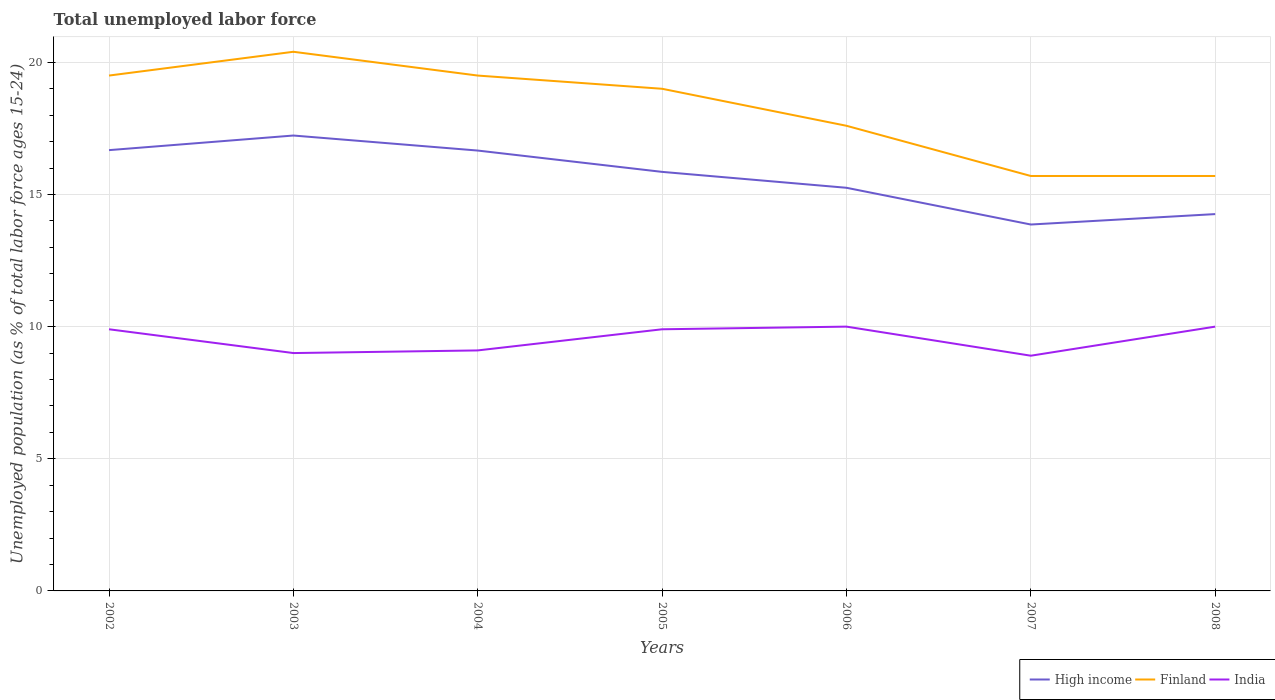Does the line corresponding to Finland intersect with the line corresponding to India?
Your answer should be very brief. No. Across all years, what is the maximum percentage of unemployed population in in High income?
Make the answer very short. 13.86. In which year was the percentage of unemployed population in in Finland maximum?
Your answer should be compact. 2007. What is the total percentage of unemployed population in in High income in the graph?
Make the answer very short. 1.42. What is the difference between the highest and the second highest percentage of unemployed population in in India?
Ensure brevity in your answer.  1.1. What is the difference between the highest and the lowest percentage of unemployed population in in India?
Offer a terse response. 4. How many years are there in the graph?
Give a very brief answer. 7. How many legend labels are there?
Your response must be concise. 3. What is the title of the graph?
Your response must be concise. Total unemployed labor force. Does "Israel" appear as one of the legend labels in the graph?
Your answer should be compact. No. What is the label or title of the Y-axis?
Provide a short and direct response. Unemployed population (as % of total labor force ages 15-24). What is the Unemployed population (as % of total labor force ages 15-24) of High income in 2002?
Your answer should be very brief. 16.68. What is the Unemployed population (as % of total labor force ages 15-24) of Finland in 2002?
Provide a short and direct response. 19.5. What is the Unemployed population (as % of total labor force ages 15-24) in India in 2002?
Your answer should be very brief. 9.9. What is the Unemployed population (as % of total labor force ages 15-24) of High income in 2003?
Your answer should be very brief. 17.23. What is the Unemployed population (as % of total labor force ages 15-24) of Finland in 2003?
Keep it short and to the point. 20.4. What is the Unemployed population (as % of total labor force ages 15-24) of High income in 2004?
Ensure brevity in your answer.  16.66. What is the Unemployed population (as % of total labor force ages 15-24) in Finland in 2004?
Keep it short and to the point. 19.5. What is the Unemployed population (as % of total labor force ages 15-24) in India in 2004?
Provide a succinct answer. 9.1. What is the Unemployed population (as % of total labor force ages 15-24) of High income in 2005?
Your answer should be very brief. 15.86. What is the Unemployed population (as % of total labor force ages 15-24) in Finland in 2005?
Ensure brevity in your answer.  19. What is the Unemployed population (as % of total labor force ages 15-24) in India in 2005?
Offer a terse response. 9.9. What is the Unemployed population (as % of total labor force ages 15-24) of High income in 2006?
Your response must be concise. 15.25. What is the Unemployed population (as % of total labor force ages 15-24) of Finland in 2006?
Your answer should be very brief. 17.6. What is the Unemployed population (as % of total labor force ages 15-24) in India in 2006?
Your answer should be very brief. 10. What is the Unemployed population (as % of total labor force ages 15-24) in High income in 2007?
Provide a succinct answer. 13.86. What is the Unemployed population (as % of total labor force ages 15-24) in Finland in 2007?
Offer a terse response. 15.7. What is the Unemployed population (as % of total labor force ages 15-24) of India in 2007?
Provide a succinct answer. 8.9. What is the Unemployed population (as % of total labor force ages 15-24) in High income in 2008?
Ensure brevity in your answer.  14.26. What is the Unemployed population (as % of total labor force ages 15-24) in Finland in 2008?
Provide a short and direct response. 15.7. Across all years, what is the maximum Unemployed population (as % of total labor force ages 15-24) of High income?
Ensure brevity in your answer.  17.23. Across all years, what is the maximum Unemployed population (as % of total labor force ages 15-24) of Finland?
Make the answer very short. 20.4. Across all years, what is the minimum Unemployed population (as % of total labor force ages 15-24) in High income?
Offer a terse response. 13.86. Across all years, what is the minimum Unemployed population (as % of total labor force ages 15-24) in Finland?
Your answer should be compact. 15.7. Across all years, what is the minimum Unemployed population (as % of total labor force ages 15-24) in India?
Ensure brevity in your answer.  8.9. What is the total Unemployed population (as % of total labor force ages 15-24) of High income in the graph?
Provide a succinct answer. 109.8. What is the total Unemployed population (as % of total labor force ages 15-24) in Finland in the graph?
Ensure brevity in your answer.  127.4. What is the total Unemployed population (as % of total labor force ages 15-24) in India in the graph?
Keep it short and to the point. 66.8. What is the difference between the Unemployed population (as % of total labor force ages 15-24) of High income in 2002 and that in 2003?
Ensure brevity in your answer.  -0.55. What is the difference between the Unemployed population (as % of total labor force ages 15-24) in Finland in 2002 and that in 2003?
Offer a terse response. -0.9. What is the difference between the Unemployed population (as % of total labor force ages 15-24) of High income in 2002 and that in 2004?
Ensure brevity in your answer.  0.02. What is the difference between the Unemployed population (as % of total labor force ages 15-24) in Finland in 2002 and that in 2004?
Give a very brief answer. 0. What is the difference between the Unemployed population (as % of total labor force ages 15-24) in High income in 2002 and that in 2005?
Your answer should be very brief. 0.82. What is the difference between the Unemployed population (as % of total labor force ages 15-24) in Finland in 2002 and that in 2005?
Your answer should be very brief. 0.5. What is the difference between the Unemployed population (as % of total labor force ages 15-24) in India in 2002 and that in 2005?
Provide a short and direct response. 0. What is the difference between the Unemployed population (as % of total labor force ages 15-24) of High income in 2002 and that in 2006?
Provide a succinct answer. 1.42. What is the difference between the Unemployed population (as % of total labor force ages 15-24) in High income in 2002 and that in 2007?
Your answer should be compact. 2.81. What is the difference between the Unemployed population (as % of total labor force ages 15-24) in High income in 2002 and that in 2008?
Make the answer very short. 2.42. What is the difference between the Unemployed population (as % of total labor force ages 15-24) of High income in 2003 and that in 2004?
Make the answer very short. 0.57. What is the difference between the Unemployed population (as % of total labor force ages 15-24) of Finland in 2003 and that in 2004?
Your answer should be very brief. 0.9. What is the difference between the Unemployed population (as % of total labor force ages 15-24) in High income in 2003 and that in 2005?
Make the answer very short. 1.38. What is the difference between the Unemployed population (as % of total labor force ages 15-24) of Finland in 2003 and that in 2005?
Provide a succinct answer. 1.4. What is the difference between the Unemployed population (as % of total labor force ages 15-24) in India in 2003 and that in 2005?
Provide a succinct answer. -0.9. What is the difference between the Unemployed population (as % of total labor force ages 15-24) of High income in 2003 and that in 2006?
Provide a short and direct response. 1.98. What is the difference between the Unemployed population (as % of total labor force ages 15-24) in High income in 2003 and that in 2007?
Offer a very short reply. 3.37. What is the difference between the Unemployed population (as % of total labor force ages 15-24) in High income in 2003 and that in 2008?
Provide a succinct answer. 2.97. What is the difference between the Unemployed population (as % of total labor force ages 15-24) in India in 2003 and that in 2008?
Provide a succinct answer. -1. What is the difference between the Unemployed population (as % of total labor force ages 15-24) in High income in 2004 and that in 2005?
Provide a succinct answer. 0.81. What is the difference between the Unemployed population (as % of total labor force ages 15-24) of Finland in 2004 and that in 2005?
Make the answer very short. 0.5. What is the difference between the Unemployed population (as % of total labor force ages 15-24) in High income in 2004 and that in 2006?
Offer a very short reply. 1.41. What is the difference between the Unemployed population (as % of total labor force ages 15-24) in Finland in 2004 and that in 2006?
Offer a very short reply. 1.9. What is the difference between the Unemployed population (as % of total labor force ages 15-24) of India in 2004 and that in 2006?
Offer a very short reply. -0.9. What is the difference between the Unemployed population (as % of total labor force ages 15-24) of High income in 2004 and that in 2007?
Offer a terse response. 2.8. What is the difference between the Unemployed population (as % of total labor force ages 15-24) in India in 2004 and that in 2007?
Your answer should be compact. 0.2. What is the difference between the Unemployed population (as % of total labor force ages 15-24) of High income in 2004 and that in 2008?
Ensure brevity in your answer.  2.4. What is the difference between the Unemployed population (as % of total labor force ages 15-24) in High income in 2005 and that in 2006?
Give a very brief answer. 0.6. What is the difference between the Unemployed population (as % of total labor force ages 15-24) of Finland in 2005 and that in 2006?
Keep it short and to the point. 1.4. What is the difference between the Unemployed population (as % of total labor force ages 15-24) of High income in 2005 and that in 2007?
Your response must be concise. 1.99. What is the difference between the Unemployed population (as % of total labor force ages 15-24) in Finland in 2005 and that in 2007?
Provide a short and direct response. 3.3. What is the difference between the Unemployed population (as % of total labor force ages 15-24) of High income in 2005 and that in 2008?
Offer a terse response. 1.6. What is the difference between the Unemployed population (as % of total labor force ages 15-24) in Finland in 2005 and that in 2008?
Keep it short and to the point. 3.3. What is the difference between the Unemployed population (as % of total labor force ages 15-24) in High income in 2006 and that in 2007?
Keep it short and to the point. 1.39. What is the difference between the Unemployed population (as % of total labor force ages 15-24) of India in 2006 and that in 2007?
Give a very brief answer. 1.1. What is the difference between the Unemployed population (as % of total labor force ages 15-24) of High income in 2007 and that in 2008?
Your answer should be very brief. -0.39. What is the difference between the Unemployed population (as % of total labor force ages 15-24) of India in 2007 and that in 2008?
Keep it short and to the point. -1.1. What is the difference between the Unemployed population (as % of total labor force ages 15-24) of High income in 2002 and the Unemployed population (as % of total labor force ages 15-24) of Finland in 2003?
Make the answer very short. -3.72. What is the difference between the Unemployed population (as % of total labor force ages 15-24) of High income in 2002 and the Unemployed population (as % of total labor force ages 15-24) of India in 2003?
Your answer should be compact. 7.68. What is the difference between the Unemployed population (as % of total labor force ages 15-24) in Finland in 2002 and the Unemployed population (as % of total labor force ages 15-24) in India in 2003?
Your answer should be compact. 10.5. What is the difference between the Unemployed population (as % of total labor force ages 15-24) in High income in 2002 and the Unemployed population (as % of total labor force ages 15-24) in Finland in 2004?
Provide a succinct answer. -2.82. What is the difference between the Unemployed population (as % of total labor force ages 15-24) in High income in 2002 and the Unemployed population (as % of total labor force ages 15-24) in India in 2004?
Ensure brevity in your answer.  7.58. What is the difference between the Unemployed population (as % of total labor force ages 15-24) in Finland in 2002 and the Unemployed population (as % of total labor force ages 15-24) in India in 2004?
Provide a succinct answer. 10.4. What is the difference between the Unemployed population (as % of total labor force ages 15-24) in High income in 2002 and the Unemployed population (as % of total labor force ages 15-24) in Finland in 2005?
Offer a terse response. -2.32. What is the difference between the Unemployed population (as % of total labor force ages 15-24) in High income in 2002 and the Unemployed population (as % of total labor force ages 15-24) in India in 2005?
Provide a short and direct response. 6.78. What is the difference between the Unemployed population (as % of total labor force ages 15-24) in High income in 2002 and the Unemployed population (as % of total labor force ages 15-24) in Finland in 2006?
Your response must be concise. -0.92. What is the difference between the Unemployed population (as % of total labor force ages 15-24) of High income in 2002 and the Unemployed population (as % of total labor force ages 15-24) of India in 2006?
Offer a very short reply. 6.68. What is the difference between the Unemployed population (as % of total labor force ages 15-24) in Finland in 2002 and the Unemployed population (as % of total labor force ages 15-24) in India in 2006?
Your answer should be very brief. 9.5. What is the difference between the Unemployed population (as % of total labor force ages 15-24) of High income in 2002 and the Unemployed population (as % of total labor force ages 15-24) of Finland in 2007?
Offer a very short reply. 0.98. What is the difference between the Unemployed population (as % of total labor force ages 15-24) of High income in 2002 and the Unemployed population (as % of total labor force ages 15-24) of India in 2007?
Keep it short and to the point. 7.78. What is the difference between the Unemployed population (as % of total labor force ages 15-24) of Finland in 2002 and the Unemployed population (as % of total labor force ages 15-24) of India in 2007?
Give a very brief answer. 10.6. What is the difference between the Unemployed population (as % of total labor force ages 15-24) of High income in 2002 and the Unemployed population (as % of total labor force ages 15-24) of Finland in 2008?
Give a very brief answer. 0.98. What is the difference between the Unemployed population (as % of total labor force ages 15-24) in High income in 2002 and the Unemployed population (as % of total labor force ages 15-24) in India in 2008?
Your response must be concise. 6.68. What is the difference between the Unemployed population (as % of total labor force ages 15-24) in High income in 2003 and the Unemployed population (as % of total labor force ages 15-24) in Finland in 2004?
Ensure brevity in your answer.  -2.27. What is the difference between the Unemployed population (as % of total labor force ages 15-24) in High income in 2003 and the Unemployed population (as % of total labor force ages 15-24) in India in 2004?
Provide a short and direct response. 8.13. What is the difference between the Unemployed population (as % of total labor force ages 15-24) in Finland in 2003 and the Unemployed population (as % of total labor force ages 15-24) in India in 2004?
Give a very brief answer. 11.3. What is the difference between the Unemployed population (as % of total labor force ages 15-24) of High income in 2003 and the Unemployed population (as % of total labor force ages 15-24) of Finland in 2005?
Provide a short and direct response. -1.77. What is the difference between the Unemployed population (as % of total labor force ages 15-24) in High income in 2003 and the Unemployed population (as % of total labor force ages 15-24) in India in 2005?
Your answer should be very brief. 7.33. What is the difference between the Unemployed population (as % of total labor force ages 15-24) of Finland in 2003 and the Unemployed population (as % of total labor force ages 15-24) of India in 2005?
Ensure brevity in your answer.  10.5. What is the difference between the Unemployed population (as % of total labor force ages 15-24) in High income in 2003 and the Unemployed population (as % of total labor force ages 15-24) in Finland in 2006?
Your answer should be compact. -0.37. What is the difference between the Unemployed population (as % of total labor force ages 15-24) of High income in 2003 and the Unemployed population (as % of total labor force ages 15-24) of India in 2006?
Ensure brevity in your answer.  7.23. What is the difference between the Unemployed population (as % of total labor force ages 15-24) in High income in 2003 and the Unemployed population (as % of total labor force ages 15-24) in Finland in 2007?
Give a very brief answer. 1.53. What is the difference between the Unemployed population (as % of total labor force ages 15-24) of High income in 2003 and the Unemployed population (as % of total labor force ages 15-24) of India in 2007?
Ensure brevity in your answer.  8.33. What is the difference between the Unemployed population (as % of total labor force ages 15-24) in High income in 2003 and the Unemployed population (as % of total labor force ages 15-24) in Finland in 2008?
Ensure brevity in your answer.  1.53. What is the difference between the Unemployed population (as % of total labor force ages 15-24) of High income in 2003 and the Unemployed population (as % of total labor force ages 15-24) of India in 2008?
Your response must be concise. 7.23. What is the difference between the Unemployed population (as % of total labor force ages 15-24) of High income in 2004 and the Unemployed population (as % of total labor force ages 15-24) of Finland in 2005?
Make the answer very short. -2.34. What is the difference between the Unemployed population (as % of total labor force ages 15-24) in High income in 2004 and the Unemployed population (as % of total labor force ages 15-24) in India in 2005?
Offer a very short reply. 6.76. What is the difference between the Unemployed population (as % of total labor force ages 15-24) in Finland in 2004 and the Unemployed population (as % of total labor force ages 15-24) in India in 2005?
Ensure brevity in your answer.  9.6. What is the difference between the Unemployed population (as % of total labor force ages 15-24) in High income in 2004 and the Unemployed population (as % of total labor force ages 15-24) in Finland in 2006?
Your response must be concise. -0.94. What is the difference between the Unemployed population (as % of total labor force ages 15-24) in High income in 2004 and the Unemployed population (as % of total labor force ages 15-24) in India in 2006?
Your answer should be very brief. 6.66. What is the difference between the Unemployed population (as % of total labor force ages 15-24) in High income in 2004 and the Unemployed population (as % of total labor force ages 15-24) in Finland in 2007?
Your answer should be compact. 0.96. What is the difference between the Unemployed population (as % of total labor force ages 15-24) of High income in 2004 and the Unemployed population (as % of total labor force ages 15-24) of India in 2007?
Make the answer very short. 7.76. What is the difference between the Unemployed population (as % of total labor force ages 15-24) of Finland in 2004 and the Unemployed population (as % of total labor force ages 15-24) of India in 2007?
Your answer should be compact. 10.6. What is the difference between the Unemployed population (as % of total labor force ages 15-24) of High income in 2004 and the Unemployed population (as % of total labor force ages 15-24) of Finland in 2008?
Make the answer very short. 0.96. What is the difference between the Unemployed population (as % of total labor force ages 15-24) in High income in 2004 and the Unemployed population (as % of total labor force ages 15-24) in India in 2008?
Keep it short and to the point. 6.66. What is the difference between the Unemployed population (as % of total labor force ages 15-24) in Finland in 2004 and the Unemployed population (as % of total labor force ages 15-24) in India in 2008?
Your answer should be very brief. 9.5. What is the difference between the Unemployed population (as % of total labor force ages 15-24) of High income in 2005 and the Unemployed population (as % of total labor force ages 15-24) of Finland in 2006?
Provide a succinct answer. -1.74. What is the difference between the Unemployed population (as % of total labor force ages 15-24) in High income in 2005 and the Unemployed population (as % of total labor force ages 15-24) in India in 2006?
Make the answer very short. 5.86. What is the difference between the Unemployed population (as % of total labor force ages 15-24) in High income in 2005 and the Unemployed population (as % of total labor force ages 15-24) in Finland in 2007?
Provide a short and direct response. 0.16. What is the difference between the Unemployed population (as % of total labor force ages 15-24) in High income in 2005 and the Unemployed population (as % of total labor force ages 15-24) in India in 2007?
Offer a very short reply. 6.96. What is the difference between the Unemployed population (as % of total labor force ages 15-24) in High income in 2005 and the Unemployed population (as % of total labor force ages 15-24) in Finland in 2008?
Your answer should be very brief. 0.16. What is the difference between the Unemployed population (as % of total labor force ages 15-24) in High income in 2005 and the Unemployed population (as % of total labor force ages 15-24) in India in 2008?
Give a very brief answer. 5.86. What is the difference between the Unemployed population (as % of total labor force ages 15-24) in High income in 2006 and the Unemployed population (as % of total labor force ages 15-24) in Finland in 2007?
Your answer should be compact. -0.45. What is the difference between the Unemployed population (as % of total labor force ages 15-24) in High income in 2006 and the Unemployed population (as % of total labor force ages 15-24) in India in 2007?
Your answer should be compact. 6.35. What is the difference between the Unemployed population (as % of total labor force ages 15-24) of Finland in 2006 and the Unemployed population (as % of total labor force ages 15-24) of India in 2007?
Your answer should be compact. 8.7. What is the difference between the Unemployed population (as % of total labor force ages 15-24) in High income in 2006 and the Unemployed population (as % of total labor force ages 15-24) in Finland in 2008?
Your answer should be very brief. -0.45. What is the difference between the Unemployed population (as % of total labor force ages 15-24) of High income in 2006 and the Unemployed population (as % of total labor force ages 15-24) of India in 2008?
Offer a very short reply. 5.25. What is the difference between the Unemployed population (as % of total labor force ages 15-24) in High income in 2007 and the Unemployed population (as % of total labor force ages 15-24) in Finland in 2008?
Keep it short and to the point. -1.84. What is the difference between the Unemployed population (as % of total labor force ages 15-24) in High income in 2007 and the Unemployed population (as % of total labor force ages 15-24) in India in 2008?
Give a very brief answer. 3.86. What is the difference between the Unemployed population (as % of total labor force ages 15-24) of Finland in 2007 and the Unemployed population (as % of total labor force ages 15-24) of India in 2008?
Give a very brief answer. 5.7. What is the average Unemployed population (as % of total labor force ages 15-24) in High income per year?
Offer a very short reply. 15.69. What is the average Unemployed population (as % of total labor force ages 15-24) in Finland per year?
Keep it short and to the point. 18.2. What is the average Unemployed population (as % of total labor force ages 15-24) in India per year?
Your answer should be very brief. 9.54. In the year 2002, what is the difference between the Unemployed population (as % of total labor force ages 15-24) in High income and Unemployed population (as % of total labor force ages 15-24) in Finland?
Offer a very short reply. -2.82. In the year 2002, what is the difference between the Unemployed population (as % of total labor force ages 15-24) of High income and Unemployed population (as % of total labor force ages 15-24) of India?
Your answer should be very brief. 6.78. In the year 2002, what is the difference between the Unemployed population (as % of total labor force ages 15-24) of Finland and Unemployed population (as % of total labor force ages 15-24) of India?
Offer a terse response. 9.6. In the year 2003, what is the difference between the Unemployed population (as % of total labor force ages 15-24) in High income and Unemployed population (as % of total labor force ages 15-24) in Finland?
Provide a succinct answer. -3.17. In the year 2003, what is the difference between the Unemployed population (as % of total labor force ages 15-24) in High income and Unemployed population (as % of total labor force ages 15-24) in India?
Your response must be concise. 8.23. In the year 2003, what is the difference between the Unemployed population (as % of total labor force ages 15-24) of Finland and Unemployed population (as % of total labor force ages 15-24) of India?
Your answer should be very brief. 11.4. In the year 2004, what is the difference between the Unemployed population (as % of total labor force ages 15-24) in High income and Unemployed population (as % of total labor force ages 15-24) in Finland?
Ensure brevity in your answer.  -2.84. In the year 2004, what is the difference between the Unemployed population (as % of total labor force ages 15-24) in High income and Unemployed population (as % of total labor force ages 15-24) in India?
Provide a succinct answer. 7.56. In the year 2004, what is the difference between the Unemployed population (as % of total labor force ages 15-24) of Finland and Unemployed population (as % of total labor force ages 15-24) of India?
Your response must be concise. 10.4. In the year 2005, what is the difference between the Unemployed population (as % of total labor force ages 15-24) in High income and Unemployed population (as % of total labor force ages 15-24) in Finland?
Provide a short and direct response. -3.14. In the year 2005, what is the difference between the Unemployed population (as % of total labor force ages 15-24) of High income and Unemployed population (as % of total labor force ages 15-24) of India?
Keep it short and to the point. 5.96. In the year 2005, what is the difference between the Unemployed population (as % of total labor force ages 15-24) in Finland and Unemployed population (as % of total labor force ages 15-24) in India?
Ensure brevity in your answer.  9.1. In the year 2006, what is the difference between the Unemployed population (as % of total labor force ages 15-24) in High income and Unemployed population (as % of total labor force ages 15-24) in Finland?
Ensure brevity in your answer.  -2.35. In the year 2006, what is the difference between the Unemployed population (as % of total labor force ages 15-24) of High income and Unemployed population (as % of total labor force ages 15-24) of India?
Provide a short and direct response. 5.25. In the year 2006, what is the difference between the Unemployed population (as % of total labor force ages 15-24) in Finland and Unemployed population (as % of total labor force ages 15-24) in India?
Give a very brief answer. 7.6. In the year 2007, what is the difference between the Unemployed population (as % of total labor force ages 15-24) in High income and Unemployed population (as % of total labor force ages 15-24) in Finland?
Make the answer very short. -1.84. In the year 2007, what is the difference between the Unemployed population (as % of total labor force ages 15-24) of High income and Unemployed population (as % of total labor force ages 15-24) of India?
Provide a succinct answer. 4.96. In the year 2007, what is the difference between the Unemployed population (as % of total labor force ages 15-24) in Finland and Unemployed population (as % of total labor force ages 15-24) in India?
Ensure brevity in your answer.  6.8. In the year 2008, what is the difference between the Unemployed population (as % of total labor force ages 15-24) of High income and Unemployed population (as % of total labor force ages 15-24) of Finland?
Your response must be concise. -1.44. In the year 2008, what is the difference between the Unemployed population (as % of total labor force ages 15-24) of High income and Unemployed population (as % of total labor force ages 15-24) of India?
Your response must be concise. 4.26. In the year 2008, what is the difference between the Unemployed population (as % of total labor force ages 15-24) in Finland and Unemployed population (as % of total labor force ages 15-24) in India?
Keep it short and to the point. 5.7. What is the ratio of the Unemployed population (as % of total labor force ages 15-24) of High income in 2002 to that in 2003?
Your answer should be compact. 0.97. What is the ratio of the Unemployed population (as % of total labor force ages 15-24) in Finland in 2002 to that in 2003?
Your answer should be compact. 0.96. What is the ratio of the Unemployed population (as % of total labor force ages 15-24) of India in 2002 to that in 2004?
Ensure brevity in your answer.  1.09. What is the ratio of the Unemployed population (as % of total labor force ages 15-24) of High income in 2002 to that in 2005?
Your answer should be compact. 1.05. What is the ratio of the Unemployed population (as % of total labor force ages 15-24) of Finland in 2002 to that in 2005?
Provide a short and direct response. 1.03. What is the ratio of the Unemployed population (as % of total labor force ages 15-24) of High income in 2002 to that in 2006?
Provide a succinct answer. 1.09. What is the ratio of the Unemployed population (as % of total labor force ages 15-24) in Finland in 2002 to that in 2006?
Offer a terse response. 1.11. What is the ratio of the Unemployed population (as % of total labor force ages 15-24) in High income in 2002 to that in 2007?
Your response must be concise. 1.2. What is the ratio of the Unemployed population (as % of total labor force ages 15-24) of Finland in 2002 to that in 2007?
Your answer should be very brief. 1.24. What is the ratio of the Unemployed population (as % of total labor force ages 15-24) in India in 2002 to that in 2007?
Provide a short and direct response. 1.11. What is the ratio of the Unemployed population (as % of total labor force ages 15-24) of High income in 2002 to that in 2008?
Ensure brevity in your answer.  1.17. What is the ratio of the Unemployed population (as % of total labor force ages 15-24) in Finland in 2002 to that in 2008?
Give a very brief answer. 1.24. What is the ratio of the Unemployed population (as % of total labor force ages 15-24) of India in 2002 to that in 2008?
Provide a short and direct response. 0.99. What is the ratio of the Unemployed population (as % of total labor force ages 15-24) in High income in 2003 to that in 2004?
Make the answer very short. 1.03. What is the ratio of the Unemployed population (as % of total labor force ages 15-24) of Finland in 2003 to that in 2004?
Your response must be concise. 1.05. What is the ratio of the Unemployed population (as % of total labor force ages 15-24) in High income in 2003 to that in 2005?
Your response must be concise. 1.09. What is the ratio of the Unemployed population (as % of total labor force ages 15-24) of Finland in 2003 to that in 2005?
Ensure brevity in your answer.  1.07. What is the ratio of the Unemployed population (as % of total labor force ages 15-24) in India in 2003 to that in 2005?
Provide a short and direct response. 0.91. What is the ratio of the Unemployed population (as % of total labor force ages 15-24) in High income in 2003 to that in 2006?
Offer a terse response. 1.13. What is the ratio of the Unemployed population (as % of total labor force ages 15-24) in Finland in 2003 to that in 2006?
Your answer should be very brief. 1.16. What is the ratio of the Unemployed population (as % of total labor force ages 15-24) in India in 2003 to that in 2006?
Provide a short and direct response. 0.9. What is the ratio of the Unemployed population (as % of total labor force ages 15-24) in High income in 2003 to that in 2007?
Provide a succinct answer. 1.24. What is the ratio of the Unemployed population (as % of total labor force ages 15-24) of Finland in 2003 to that in 2007?
Offer a very short reply. 1.3. What is the ratio of the Unemployed population (as % of total labor force ages 15-24) of India in 2003 to that in 2007?
Make the answer very short. 1.01. What is the ratio of the Unemployed population (as % of total labor force ages 15-24) in High income in 2003 to that in 2008?
Your response must be concise. 1.21. What is the ratio of the Unemployed population (as % of total labor force ages 15-24) of Finland in 2003 to that in 2008?
Offer a terse response. 1.3. What is the ratio of the Unemployed population (as % of total labor force ages 15-24) in High income in 2004 to that in 2005?
Your answer should be very brief. 1.05. What is the ratio of the Unemployed population (as % of total labor force ages 15-24) of Finland in 2004 to that in 2005?
Your answer should be compact. 1.03. What is the ratio of the Unemployed population (as % of total labor force ages 15-24) of India in 2004 to that in 2005?
Provide a succinct answer. 0.92. What is the ratio of the Unemployed population (as % of total labor force ages 15-24) in High income in 2004 to that in 2006?
Offer a terse response. 1.09. What is the ratio of the Unemployed population (as % of total labor force ages 15-24) in Finland in 2004 to that in 2006?
Offer a very short reply. 1.11. What is the ratio of the Unemployed population (as % of total labor force ages 15-24) of India in 2004 to that in 2006?
Keep it short and to the point. 0.91. What is the ratio of the Unemployed population (as % of total labor force ages 15-24) of High income in 2004 to that in 2007?
Offer a very short reply. 1.2. What is the ratio of the Unemployed population (as % of total labor force ages 15-24) in Finland in 2004 to that in 2007?
Your response must be concise. 1.24. What is the ratio of the Unemployed population (as % of total labor force ages 15-24) in India in 2004 to that in 2007?
Keep it short and to the point. 1.02. What is the ratio of the Unemployed population (as % of total labor force ages 15-24) in High income in 2004 to that in 2008?
Keep it short and to the point. 1.17. What is the ratio of the Unemployed population (as % of total labor force ages 15-24) in Finland in 2004 to that in 2008?
Make the answer very short. 1.24. What is the ratio of the Unemployed population (as % of total labor force ages 15-24) in India in 2004 to that in 2008?
Your answer should be compact. 0.91. What is the ratio of the Unemployed population (as % of total labor force ages 15-24) of High income in 2005 to that in 2006?
Keep it short and to the point. 1.04. What is the ratio of the Unemployed population (as % of total labor force ages 15-24) in Finland in 2005 to that in 2006?
Your answer should be compact. 1.08. What is the ratio of the Unemployed population (as % of total labor force ages 15-24) of India in 2005 to that in 2006?
Offer a terse response. 0.99. What is the ratio of the Unemployed population (as % of total labor force ages 15-24) of High income in 2005 to that in 2007?
Keep it short and to the point. 1.14. What is the ratio of the Unemployed population (as % of total labor force ages 15-24) of Finland in 2005 to that in 2007?
Provide a succinct answer. 1.21. What is the ratio of the Unemployed population (as % of total labor force ages 15-24) of India in 2005 to that in 2007?
Ensure brevity in your answer.  1.11. What is the ratio of the Unemployed population (as % of total labor force ages 15-24) of High income in 2005 to that in 2008?
Make the answer very short. 1.11. What is the ratio of the Unemployed population (as % of total labor force ages 15-24) in Finland in 2005 to that in 2008?
Give a very brief answer. 1.21. What is the ratio of the Unemployed population (as % of total labor force ages 15-24) of India in 2005 to that in 2008?
Make the answer very short. 0.99. What is the ratio of the Unemployed population (as % of total labor force ages 15-24) of High income in 2006 to that in 2007?
Provide a succinct answer. 1.1. What is the ratio of the Unemployed population (as % of total labor force ages 15-24) in Finland in 2006 to that in 2007?
Make the answer very short. 1.12. What is the ratio of the Unemployed population (as % of total labor force ages 15-24) in India in 2006 to that in 2007?
Provide a succinct answer. 1.12. What is the ratio of the Unemployed population (as % of total labor force ages 15-24) of High income in 2006 to that in 2008?
Give a very brief answer. 1.07. What is the ratio of the Unemployed population (as % of total labor force ages 15-24) of Finland in 2006 to that in 2008?
Keep it short and to the point. 1.12. What is the ratio of the Unemployed population (as % of total labor force ages 15-24) in India in 2006 to that in 2008?
Keep it short and to the point. 1. What is the ratio of the Unemployed population (as % of total labor force ages 15-24) of High income in 2007 to that in 2008?
Your answer should be compact. 0.97. What is the ratio of the Unemployed population (as % of total labor force ages 15-24) in India in 2007 to that in 2008?
Offer a terse response. 0.89. What is the difference between the highest and the second highest Unemployed population (as % of total labor force ages 15-24) in High income?
Make the answer very short. 0.55. What is the difference between the highest and the lowest Unemployed population (as % of total labor force ages 15-24) in High income?
Provide a short and direct response. 3.37. What is the difference between the highest and the lowest Unemployed population (as % of total labor force ages 15-24) in Finland?
Your answer should be very brief. 4.7. 